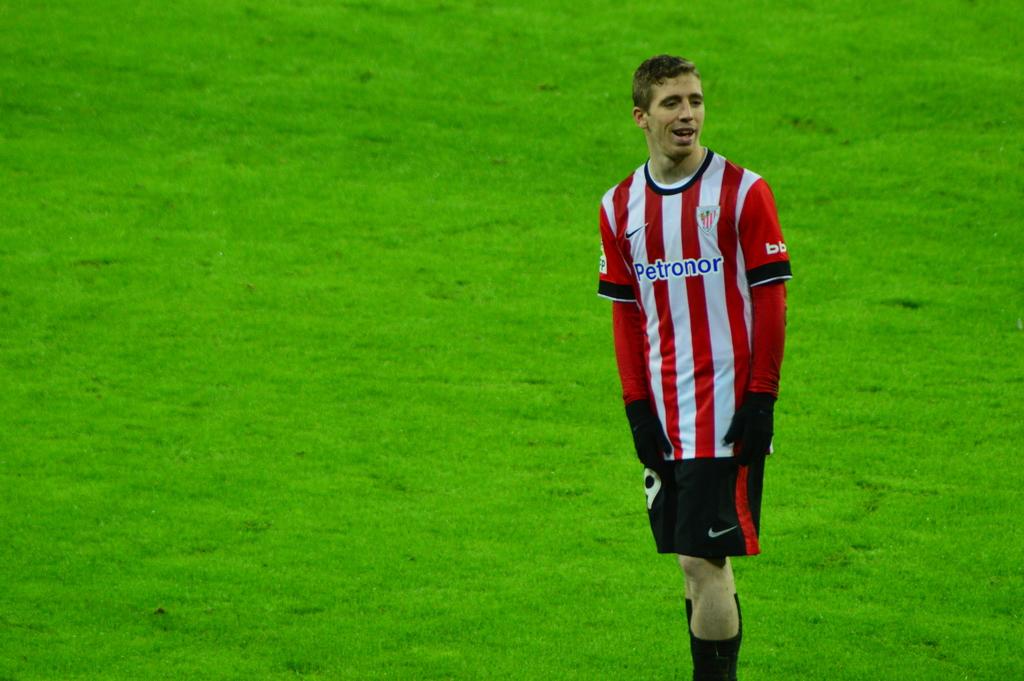What company name is the sponsor written on his shirt?
Ensure brevity in your answer.  Petronor. What is on his sleeve?
Make the answer very short. Bb. 